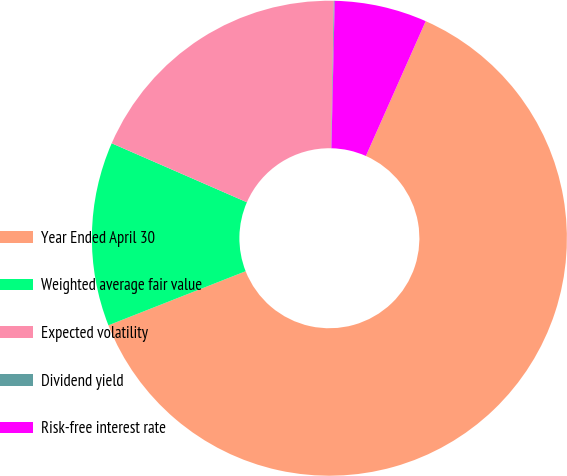Convert chart to OTSL. <chart><loc_0><loc_0><loc_500><loc_500><pie_chart><fcel>Year Ended April 30<fcel>Weighted average fair value<fcel>Expected volatility<fcel>Dividend yield<fcel>Risk-free interest rate<nl><fcel>62.38%<fcel>12.52%<fcel>18.75%<fcel>0.06%<fcel>6.29%<nl></chart> 